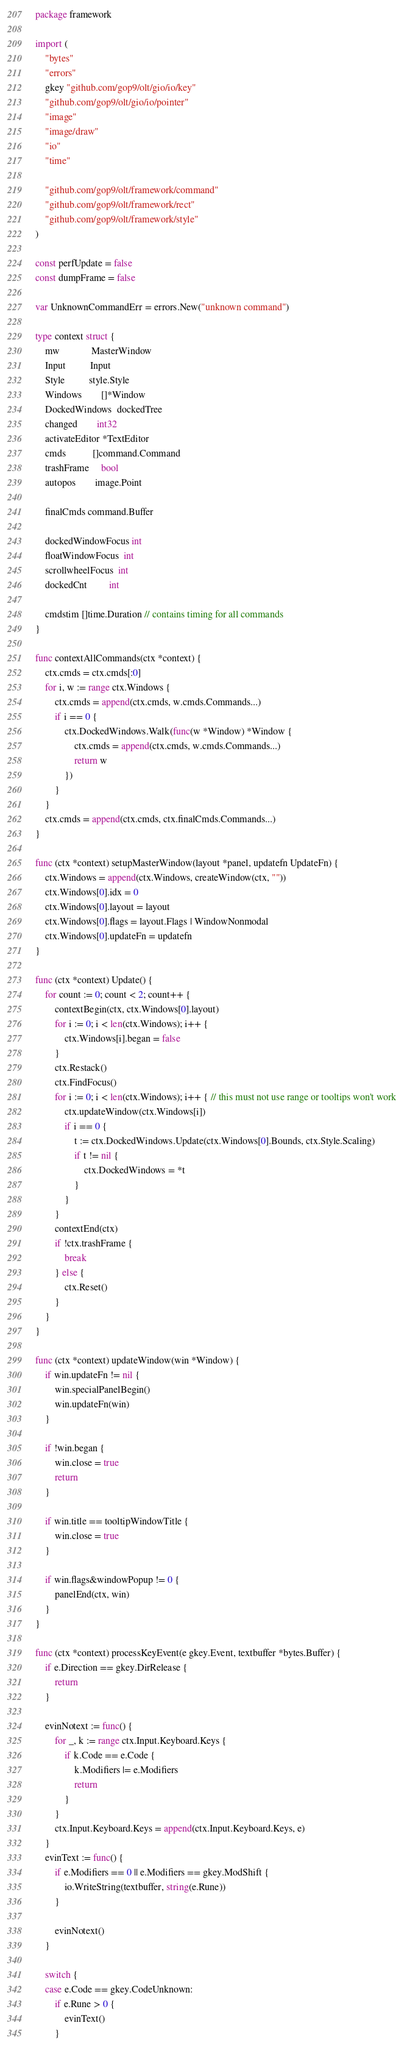<code> <loc_0><loc_0><loc_500><loc_500><_Go_>package framework

import (
	"bytes"
	"errors"
	gkey "github.com/gop9/olt/gio/io/key"
	"github.com/gop9/olt/gio/io/pointer"
	"image"
	"image/draw"
	"io"
	"time"

	"github.com/gop9/olt/framework/command"
	"github.com/gop9/olt/framework/rect"
	"github.com/gop9/olt/framework/style"
)

const perfUpdate = false
const dumpFrame = false

var UnknownCommandErr = errors.New("unknown command")

type context struct {
	mw             MasterWindow
	Input          Input
	Style          style.Style
	Windows        []*Window
	DockedWindows  dockedTree
	changed        int32
	activateEditor *TextEditor
	cmds           []command.Command
	trashFrame     bool
	autopos        image.Point

	finalCmds command.Buffer

	dockedWindowFocus int
	floatWindowFocus  int
	scrollwheelFocus  int
	dockedCnt         int

	cmdstim []time.Duration // contains timing for all commands
}

func contextAllCommands(ctx *context) {
	ctx.cmds = ctx.cmds[:0]
	for i, w := range ctx.Windows {
		ctx.cmds = append(ctx.cmds, w.cmds.Commands...)
		if i == 0 {
			ctx.DockedWindows.Walk(func(w *Window) *Window {
				ctx.cmds = append(ctx.cmds, w.cmds.Commands...)
				return w
			})
		}
	}
	ctx.cmds = append(ctx.cmds, ctx.finalCmds.Commands...)
}

func (ctx *context) setupMasterWindow(layout *panel, updatefn UpdateFn) {
	ctx.Windows = append(ctx.Windows, createWindow(ctx, ""))
	ctx.Windows[0].idx = 0
	ctx.Windows[0].layout = layout
	ctx.Windows[0].flags = layout.Flags | WindowNonmodal
	ctx.Windows[0].updateFn = updatefn
}

func (ctx *context) Update() {
	for count := 0; count < 2; count++ {
		contextBegin(ctx, ctx.Windows[0].layout)
		for i := 0; i < len(ctx.Windows); i++ {
			ctx.Windows[i].began = false
		}
		ctx.Restack()
		ctx.FindFocus()
		for i := 0; i < len(ctx.Windows); i++ { // this must not use range or tooltips won't work
			ctx.updateWindow(ctx.Windows[i])
			if i == 0 {
				t := ctx.DockedWindows.Update(ctx.Windows[0].Bounds, ctx.Style.Scaling)
				if t != nil {
					ctx.DockedWindows = *t
				}
			}
		}
		contextEnd(ctx)
		if !ctx.trashFrame {
			break
		} else {
			ctx.Reset()
		}
	}
}

func (ctx *context) updateWindow(win *Window) {
	if win.updateFn != nil {
		win.specialPanelBegin()
		win.updateFn(win)
	}

	if !win.began {
		win.close = true
		return
	}

	if win.title == tooltipWindowTitle {
		win.close = true
	}

	if win.flags&windowPopup != 0 {
		panelEnd(ctx, win)
	}
}

func (ctx *context) processKeyEvent(e gkey.Event, textbuffer *bytes.Buffer) {
	if e.Direction == gkey.DirRelease {
		return
	}

	evinNotext := func() {
		for _, k := range ctx.Input.Keyboard.Keys {
			if k.Code == e.Code {
				k.Modifiers |= e.Modifiers
				return
			}
		}
		ctx.Input.Keyboard.Keys = append(ctx.Input.Keyboard.Keys, e)
	}
	evinText := func() {
		if e.Modifiers == 0 || e.Modifiers == gkey.ModShift {
			io.WriteString(textbuffer, string(e.Rune))
		}

		evinNotext()
	}

	switch {
	case e.Code == gkey.CodeUnknown:
		if e.Rune > 0 {
			evinText()
		}</code> 